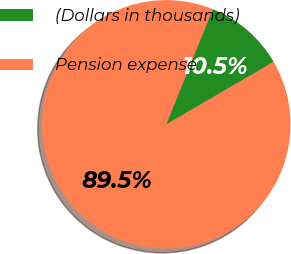<chart> <loc_0><loc_0><loc_500><loc_500><pie_chart><fcel>(Dollars in thousands)<fcel>Pension expense<nl><fcel>10.5%<fcel>89.5%<nl></chart> 